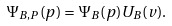<formula> <loc_0><loc_0><loc_500><loc_500>\Psi _ { B , P } ( { p } ) = \Psi _ { B } ( { p } ) U _ { B } ( v ) .</formula> 